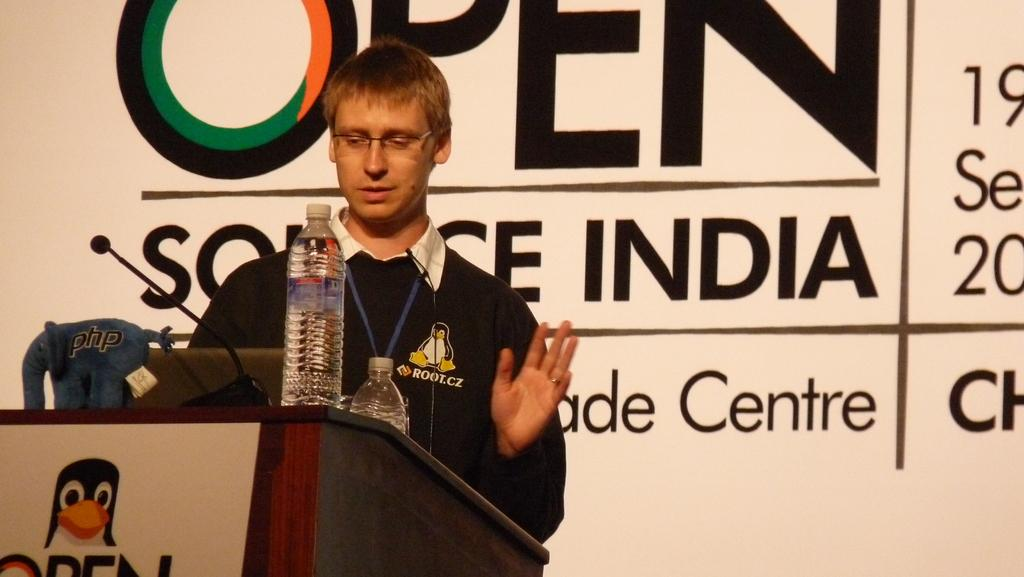<image>
Share a concise interpretation of the image provided. A man stands in front of a podium that says Open and has a penguin on it. 